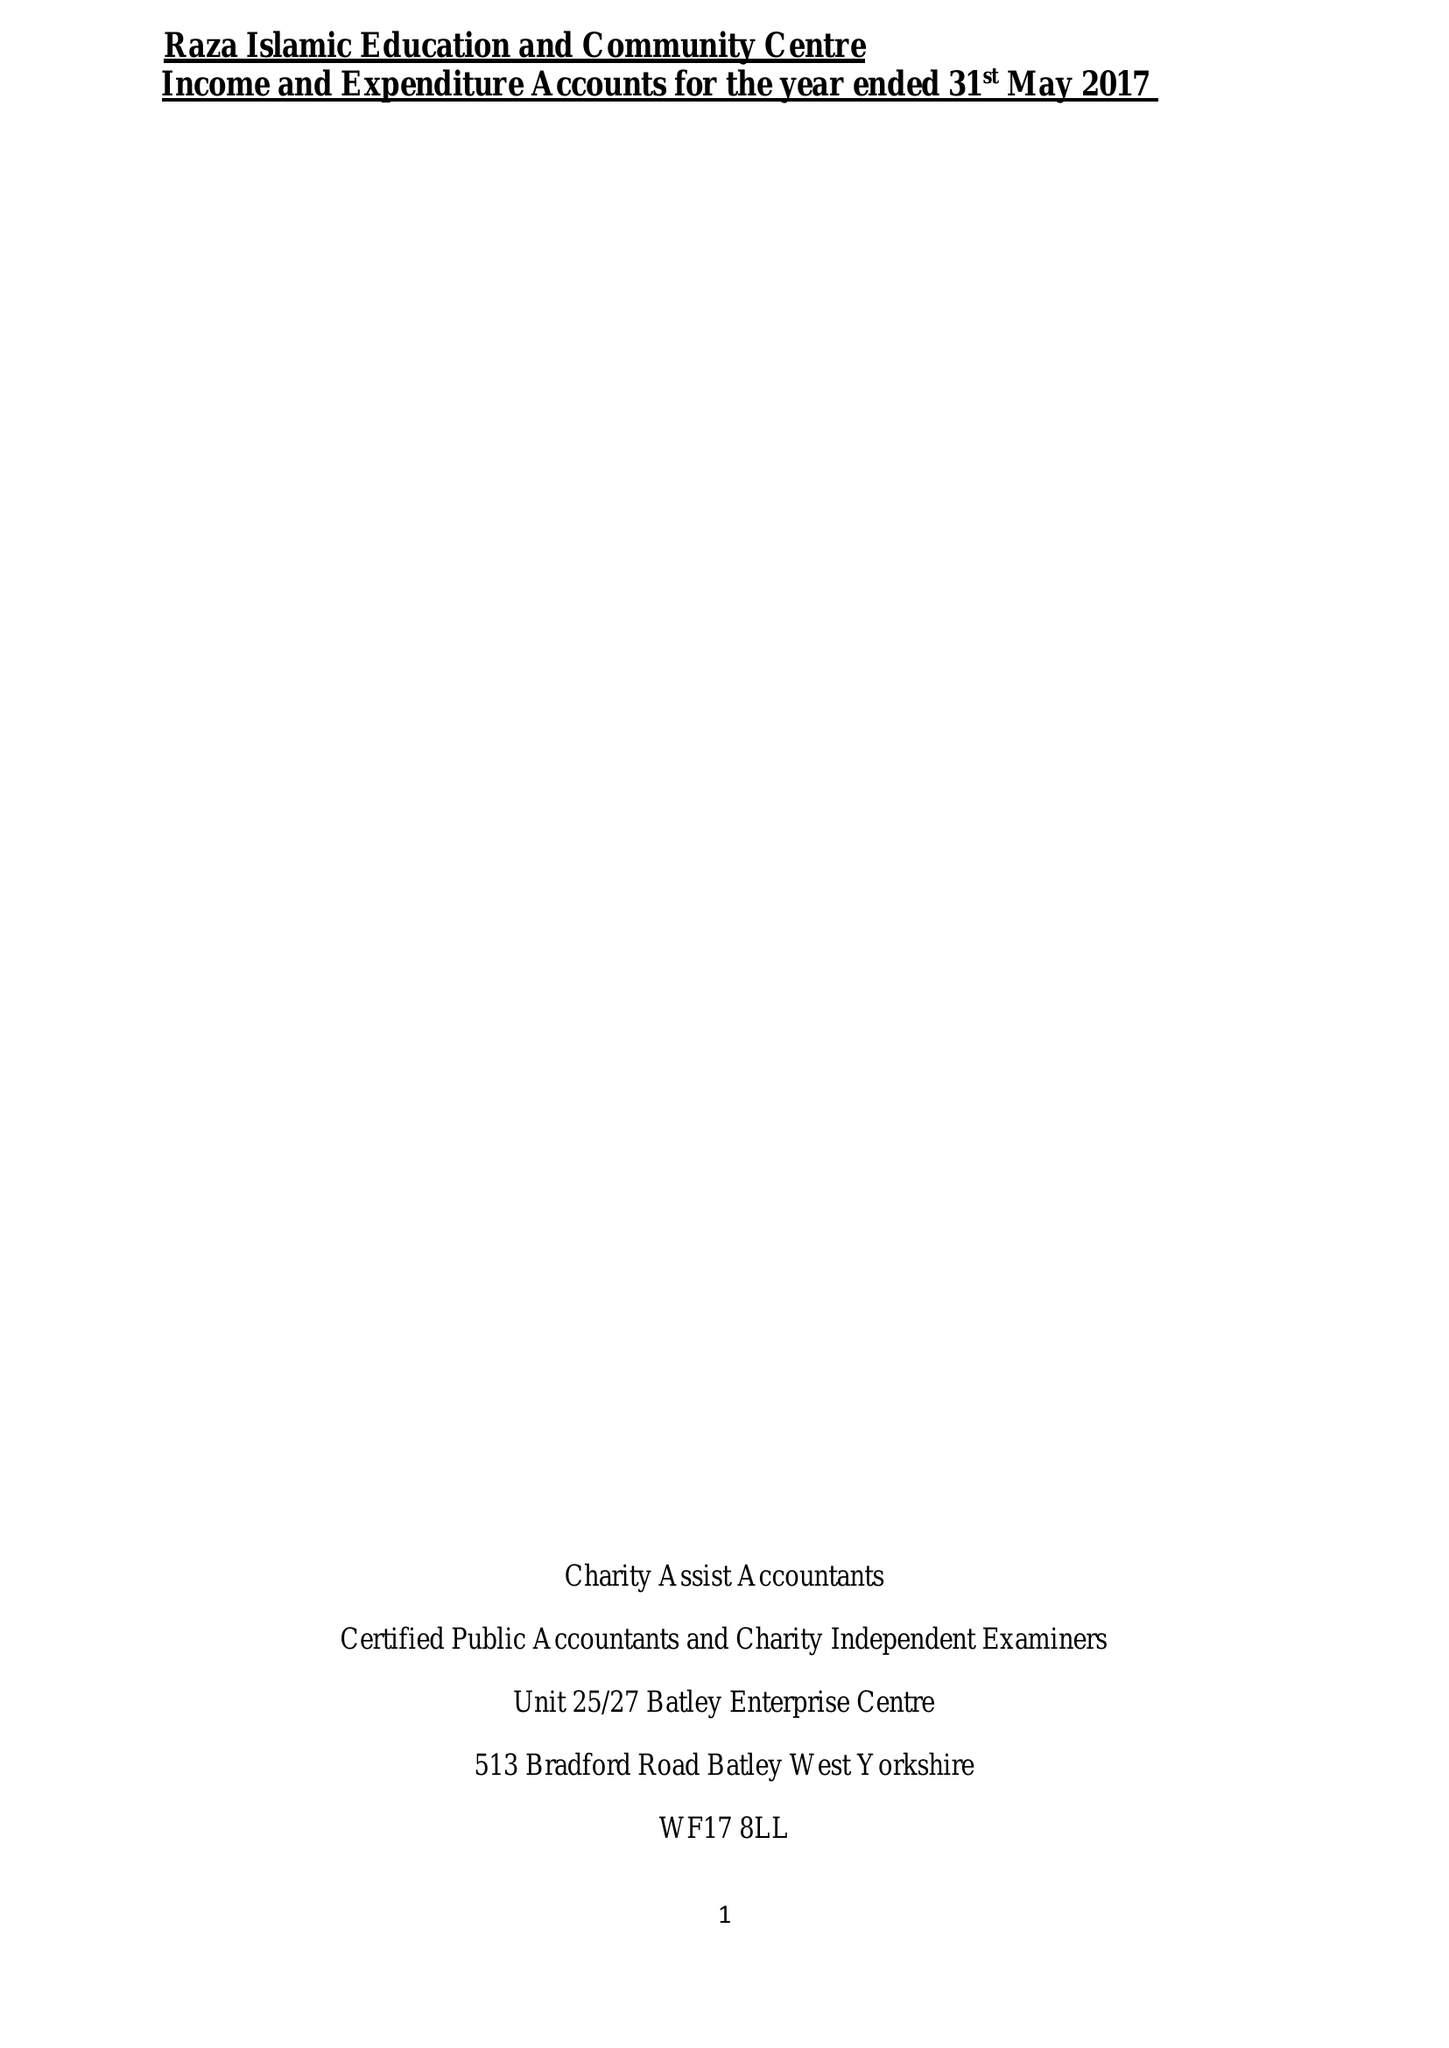What is the value for the charity_name?
Answer the question using a single word or phrase. Raza Islamic Education and Community Centre 